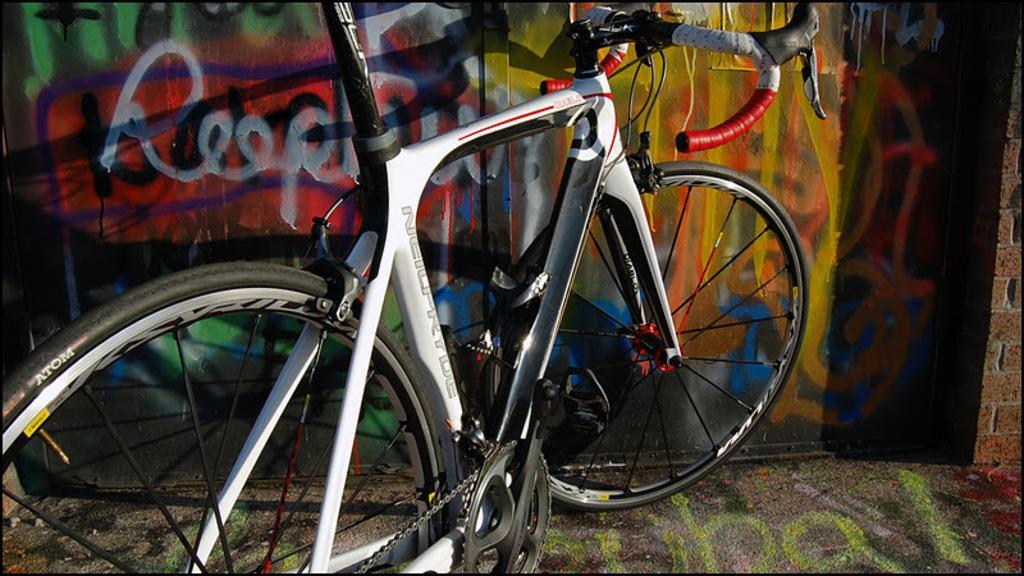How would you summarize this image in a sentence or two? This picture is clicked outside. In the center there is a white color bicycle parked on the ground. In the background we can see the wall and the art of graffiti on the wall. 